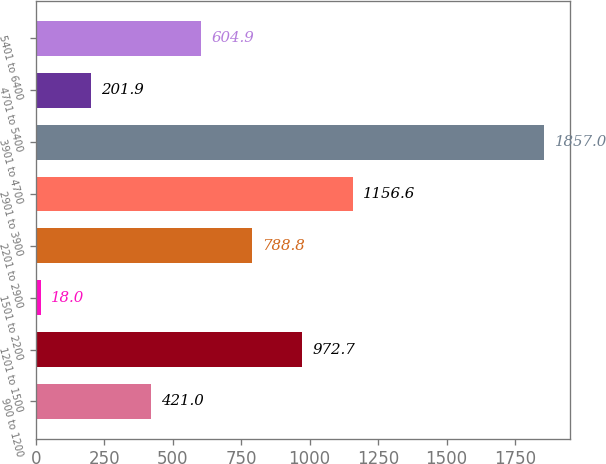Convert chart to OTSL. <chart><loc_0><loc_0><loc_500><loc_500><bar_chart><fcel>900 to 1200<fcel>1201 to 1500<fcel>1501 to 2200<fcel>2201 to 2900<fcel>2901 to 3900<fcel>3901 to 4700<fcel>4701 to 5400<fcel>5401 to 6400<nl><fcel>421<fcel>972.7<fcel>18<fcel>788.8<fcel>1156.6<fcel>1857<fcel>201.9<fcel>604.9<nl></chart> 